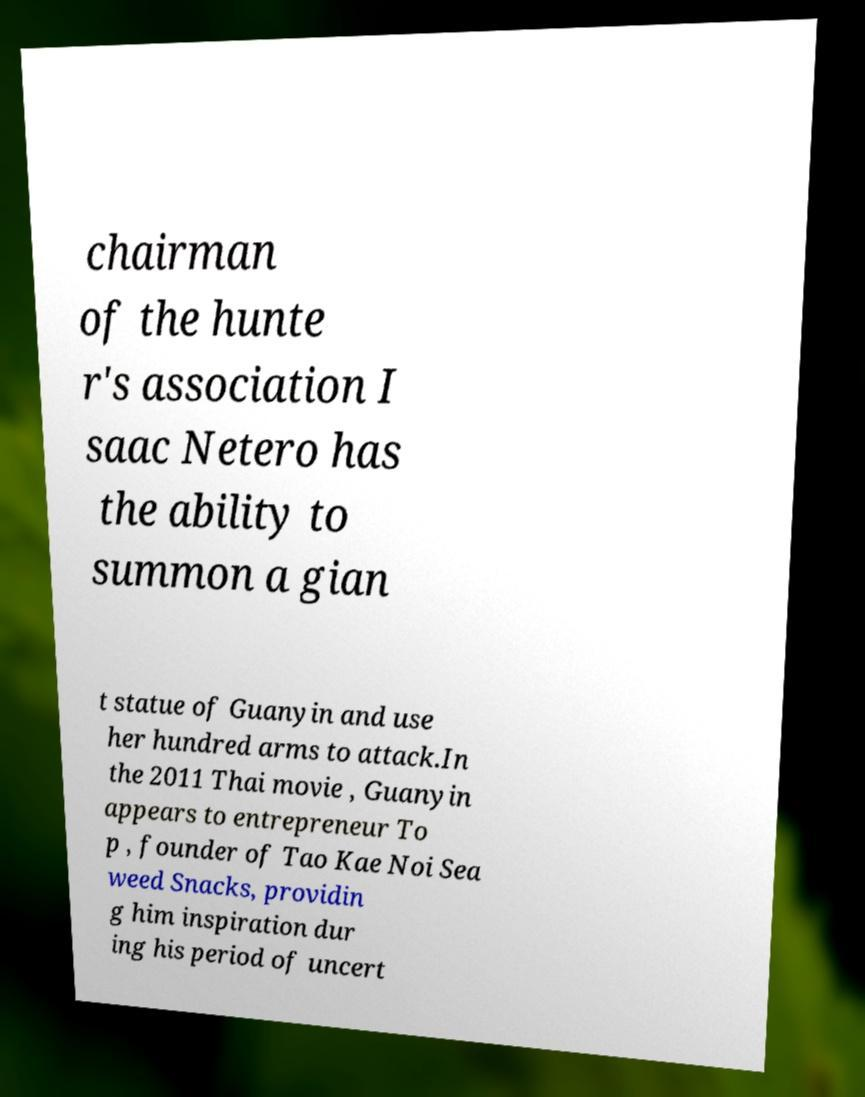Could you assist in decoding the text presented in this image and type it out clearly? chairman of the hunte r's association I saac Netero has the ability to summon a gian t statue of Guanyin and use her hundred arms to attack.In the 2011 Thai movie , Guanyin appears to entrepreneur To p , founder of Tao Kae Noi Sea weed Snacks, providin g him inspiration dur ing his period of uncert 